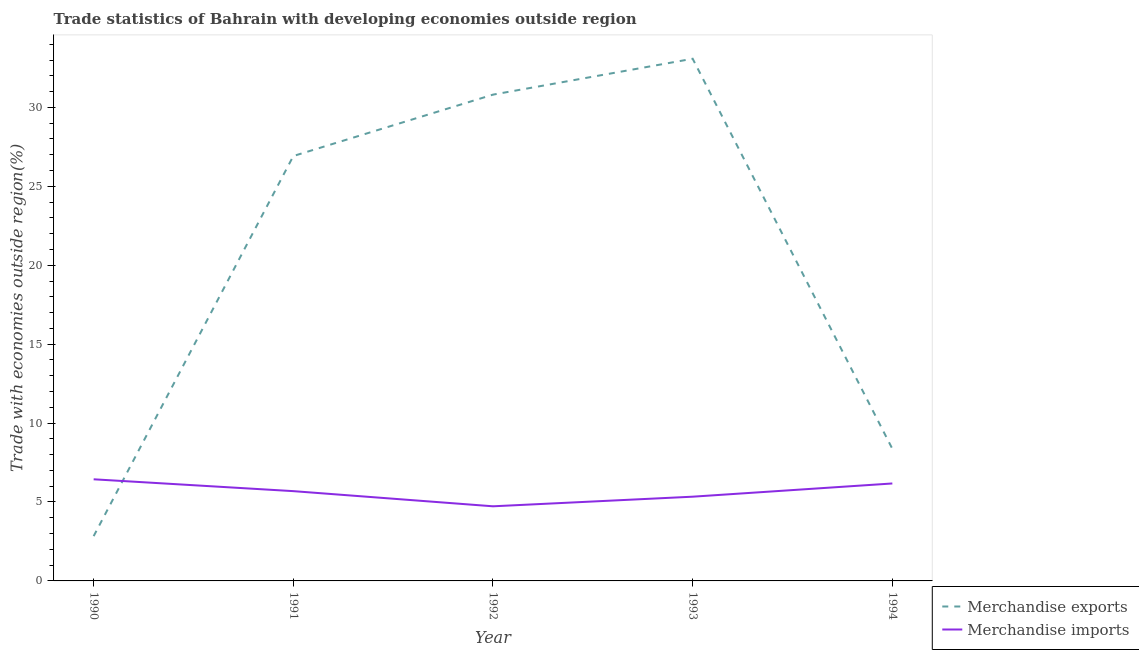What is the merchandise imports in 1994?
Offer a very short reply. 6.17. Across all years, what is the maximum merchandise exports?
Make the answer very short. 33.08. Across all years, what is the minimum merchandise imports?
Your answer should be very brief. 4.73. In which year was the merchandise imports minimum?
Offer a very short reply. 1992. What is the total merchandise exports in the graph?
Make the answer very short. 102.01. What is the difference between the merchandise imports in 1991 and that in 1994?
Provide a succinct answer. -0.49. What is the difference between the merchandise imports in 1994 and the merchandise exports in 1990?
Make the answer very short. 3.34. What is the average merchandise exports per year?
Your answer should be very brief. 20.4. In the year 1991, what is the difference between the merchandise exports and merchandise imports?
Offer a terse response. 21.23. In how many years, is the merchandise exports greater than 10 %?
Your response must be concise. 3. What is the ratio of the merchandise imports in 1990 to that in 1994?
Your answer should be very brief. 1.04. Is the merchandise exports in 1992 less than that in 1994?
Give a very brief answer. No. Is the difference between the merchandise imports in 1991 and 1994 greater than the difference between the merchandise exports in 1991 and 1994?
Your answer should be very brief. No. What is the difference between the highest and the second highest merchandise exports?
Provide a succinct answer. 2.27. What is the difference between the highest and the lowest merchandise exports?
Provide a succinct answer. 30.24. Is the sum of the merchandise imports in 1991 and 1994 greater than the maximum merchandise exports across all years?
Provide a short and direct response. No. Is the merchandise imports strictly greater than the merchandise exports over the years?
Your response must be concise. No. How many years are there in the graph?
Your answer should be very brief. 5. What is the difference between two consecutive major ticks on the Y-axis?
Your response must be concise. 5. Are the values on the major ticks of Y-axis written in scientific E-notation?
Keep it short and to the point. No. Does the graph contain any zero values?
Your answer should be very brief. No. Where does the legend appear in the graph?
Provide a short and direct response. Bottom right. What is the title of the graph?
Your answer should be very brief. Trade statistics of Bahrain with developing economies outside region. What is the label or title of the X-axis?
Give a very brief answer. Year. What is the label or title of the Y-axis?
Your answer should be very brief. Trade with economies outside region(%). What is the Trade with economies outside region(%) in Merchandise exports in 1990?
Offer a terse response. 2.84. What is the Trade with economies outside region(%) of Merchandise imports in 1990?
Keep it short and to the point. 6.44. What is the Trade with economies outside region(%) of Merchandise exports in 1991?
Provide a short and direct response. 26.92. What is the Trade with economies outside region(%) in Merchandise imports in 1991?
Ensure brevity in your answer.  5.69. What is the Trade with economies outside region(%) of Merchandise exports in 1992?
Your response must be concise. 30.81. What is the Trade with economies outside region(%) in Merchandise imports in 1992?
Your answer should be very brief. 4.73. What is the Trade with economies outside region(%) of Merchandise exports in 1993?
Provide a succinct answer. 33.08. What is the Trade with economies outside region(%) of Merchandise imports in 1993?
Keep it short and to the point. 5.34. What is the Trade with economies outside region(%) of Merchandise exports in 1994?
Make the answer very short. 8.37. What is the Trade with economies outside region(%) in Merchandise imports in 1994?
Offer a terse response. 6.17. Across all years, what is the maximum Trade with economies outside region(%) in Merchandise exports?
Ensure brevity in your answer.  33.08. Across all years, what is the maximum Trade with economies outside region(%) of Merchandise imports?
Your response must be concise. 6.44. Across all years, what is the minimum Trade with economies outside region(%) in Merchandise exports?
Ensure brevity in your answer.  2.84. Across all years, what is the minimum Trade with economies outside region(%) in Merchandise imports?
Give a very brief answer. 4.73. What is the total Trade with economies outside region(%) of Merchandise exports in the graph?
Give a very brief answer. 102.01. What is the total Trade with economies outside region(%) in Merchandise imports in the graph?
Give a very brief answer. 28.36. What is the difference between the Trade with economies outside region(%) in Merchandise exports in 1990 and that in 1991?
Provide a short and direct response. -24.08. What is the difference between the Trade with economies outside region(%) in Merchandise imports in 1990 and that in 1991?
Your answer should be very brief. 0.75. What is the difference between the Trade with economies outside region(%) of Merchandise exports in 1990 and that in 1992?
Ensure brevity in your answer.  -27.97. What is the difference between the Trade with economies outside region(%) in Merchandise imports in 1990 and that in 1992?
Your answer should be compact. 1.71. What is the difference between the Trade with economies outside region(%) in Merchandise exports in 1990 and that in 1993?
Your answer should be compact. -30.24. What is the difference between the Trade with economies outside region(%) in Merchandise imports in 1990 and that in 1993?
Your answer should be very brief. 1.1. What is the difference between the Trade with economies outside region(%) of Merchandise exports in 1990 and that in 1994?
Offer a very short reply. -5.53. What is the difference between the Trade with economies outside region(%) in Merchandise imports in 1990 and that in 1994?
Your answer should be compact. 0.26. What is the difference between the Trade with economies outside region(%) in Merchandise exports in 1991 and that in 1992?
Your answer should be compact. -3.89. What is the difference between the Trade with economies outside region(%) of Merchandise imports in 1991 and that in 1992?
Provide a short and direct response. 0.96. What is the difference between the Trade with economies outside region(%) in Merchandise exports in 1991 and that in 1993?
Provide a short and direct response. -6.16. What is the difference between the Trade with economies outside region(%) in Merchandise imports in 1991 and that in 1993?
Offer a terse response. 0.35. What is the difference between the Trade with economies outside region(%) in Merchandise exports in 1991 and that in 1994?
Ensure brevity in your answer.  18.55. What is the difference between the Trade with economies outside region(%) in Merchandise imports in 1991 and that in 1994?
Give a very brief answer. -0.49. What is the difference between the Trade with economies outside region(%) in Merchandise exports in 1992 and that in 1993?
Offer a very short reply. -2.27. What is the difference between the Trade with economies outside region(%) in Merchandise imports in 1992 and that in 1993?
Offer a terse response. -0.61. What is the difference between the Trade with economies outside region(%) of Merchandise exports in 1992 and that in 1994?
Your answer should be very brief. 22.44. What is the difference between the Trade with economies outside region(%) in Merchandise imports in 1992 and that in 1994?
Your answer should be very brief. -1.45. What is the difference between the Trade with economies outside region(%) in Merchandise exports in 1993 and that in 1994?
Your answer should be compact. 24.71. What is the difference between the Trade with economies outside region(%) of Merchandise imports in 1993 and that in 1994?
Your response must be concise. -0.84. What is the difference between the Trade with economies outside region(%) in Merchandise exports in 1990 and the Trade with economies outside region(%) in Merchandise imports in 1991?
Your answer should be compact. -2.85. What is the difference between the Trade with economies outside region(%) in Merchandise exports in 1990 and the Trade with economies outside region(%) in Merchandise imports in 1992?
Keep it short and to the point. -1.89. What is the difference between the Trade with economies outside region(%) in Merchandise exports in 1990 and the Trade with economies outside region(%) in Merchandise imports in 1993?
Give a very brief answer. -2.5. What is the difference between the Trade with economies outside region(%) in Merchandise exports in 1990 and the Trade with economies outside region(%) in Merchandise imports in 1994?
Give a very brief answer. -3.34. What is the difference between the Trade with economies outside region(%) of Merchandise exports in 1991 and the Trade with economies outside region(%) of Merchandise imports in 1992?
Your answer should be very brief. 22.19. What is the difference between the Trade with economies outside region(%) in Merchandise exports in 1991 and the Trade with economies outside region(%) in Merchandise imports in 1993?
Make the answer very short. 21.58. What is the difference between the Trade with economies outside region(%) of Merchandise exports in 1991 and the Trade with economies outside region(%) of Merchandise imports in 1994?
Keep it short and to the point. 20.74. What is the difference between the Trade with economies outside region(%) in Merchandise exports in 1992 and the Trade with economies outside region(%) in Merchandise imports in 1993?
Your answer should be compact. 25.47. What is the difference between the Trade with economies outside region(%) of Merchandise exports in 1992 and the Trade with economies outside region(%) of Merchandise imports in 1994?
Offer a very short reply. 24.63. What is the difference between the Trade with economies outside region(%) in Merchandise exports in 1993 and the Trade with economies outside region(%) in Merchandise imports in 1994?
Your answer should be very brief. 26.91. What is the average Trade with economies outside region(%) of Merchandise exports per year?
Your answer should be compact. 20.4. What is the average Trade with economies outside region(%) of Merchandise imports per year?
Provide a short and direct response. 5.67. In the year 1990, what is the difference between the Trade with economies outside region(%) in Merchandise exports and Trade with economies outside region(%) in Merchandise imports?
Your answer should be compact. -3.6. In the year 1991, what is the difference between the Trade with economies outside region(%) in Merchandise exports and Trade with economies outside region(%) in Merchandise imports?
Make the answer very short. 21.23. In the year 1992, what is the difference between the Trade with economies outside region(%) of Merchandise exports and Trade with economies outside region(%) of Merchandise imports?
Keep it short and to the point. 26.08. In the year 1993, what is the difference between the Trade with economies outside region(%) of Merchandise exports and Trade with economies outside region(%) of Merchandise imports?
Ensure brevity in your answer.  27.74. In the year 1994, what is the difference between the Trade with economies outside region(%) in Merchandise exports and Trade with economies outside region(%) in Merchandise imports?
Your answer should be very brief. 2.19. What is the ratio of the Trade with economies outside region(%) in Merchandise exports in 1990 to that in 1991?
Provide a succinct answer. 0.11. What is the ratio of the Trade with economies outside region(%) of Merchandise imports in 1990 to that in 1991?
Keep it short and to the point. 1.13. What is the ratio of the Trade with economies outside region(%) of Merchandise exports in 1990 to that in 1992?
Provide a succinct answer. 0.09. What is the ratio of the Trade with economies outside region(%) in Merchandise imports in 1990 to that in 1992?
Your response must be concise. 1.36. What is the ratio of the Trade with economies outside region(%) in Merchandise exports in 1990 to that in 1993?
Offer a very short reply. 0.09. What is the ratio of the Trade with economies outside region(%) of Merchandise imports in 1990 to that in 1993?
Offer a very short reply. 1.21. What is the ratio of the Trade with economies outside region(%) of Merchandise exports in 1990 to that in 1994?
Provide a short and direct response. 0.34. What is the ratio of the Trade with economies outside region(%) of Merchandise imports in 1990 to that in 1994?
Ensure brevity in your answer.  1.04. What is the ratio of the Trade with economies outside region(%) in Merchandise exports in 1991 to that in 1992?
Offer a terse response. 0.87. What is the ratio of the Trade with economies outside region(%) in Merchandise imports in 1991 to that in 1992?
Offer a very short reply. 1.2. What is the ratio of the Trade with economies outside region(%) of Merchandise exports in 1991 to that in 1993?
Offer a very short reply. 0.81. What is the ratio of the Trade with economies outside region(%) in Merchandise imports in 1991 to that in 1993?
Provide a short and direct response. 1.07. What is the ratio of the Trade with economies outside region(%) of Merchandise exports in 1991 to that in 1994?
Make the answer very short. 3.22. What is the ratio of the Trade with economies outside region(%) in Merchandise imports in 1991 to that in 1994?
Provide a short and direct response. 0.92. What is the ratio of the Trade with economies outside region(%) in Merchandise exports in 1992 to that in 1993?
Ensure brevity in your answer.  0.93. What is the ratio of the Trade with economies outside region(%) of Merchandise imports in 1992 to that in 1993?
Provide a succinct answer. 0.89. What is the ratio of the Trade with economies outside region(%) of Merchandise exports in 1992 to that in 1994?
Make the answer very short. 3.68. What is the ratio of the Trade with economies outside region(%) of Merchandise imports in 1992 to that in 1994?
Offer a terse response. 0.77. What is the ratio of the Trade with economies outside region(%) of Merchandise exports in 1993 to that in 1994?
Offer a very short reply. 3.95. What is the ratio of the Trade with economies outside region(%) in Merchandise imports in 1993 to that in 1994?
Keep it short and to the point. 0.86. What is the difference between the highest and the second highest Trade with economies outside region(%) of Merchandise exports?
Keep it short and to the point. 2.27. What is the difference between the highest and the second highest Trade with economies outside region(%) of Merchandise imports?
Your response must be concise. 0.26. What is the difference between the highest and the lowest Trade with economies outside region(%) of Merchandise exports?
Offer a very short reply. 30.24. What is the difference between the highest and the lowest Trade with economies outside region(%) in Merchandise imports?
Ensure brevity in your answer.  1.71. 